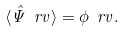<formula> <loc_0><loc_0><loc_500><loc_500>\langle \hat { \Psi } \ r v \rangle = \phi \ r v .</formula> 